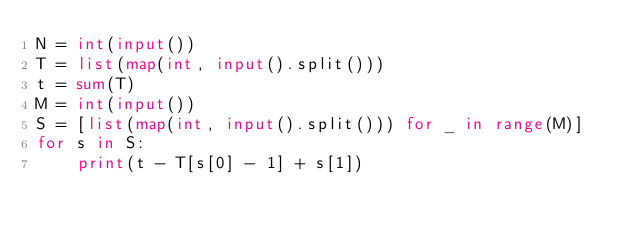<code> <loc_0><loc_0><loc_500><loc_500><_Python_>N = int(input())
T = list(map(int, input().split()))
t = sum(T)
M = int(input())
S = [list(map(int, input().split())) for _ in range(M)]
for s in S:
    print(t - T[s[0] - 1] + s[1])</code> 